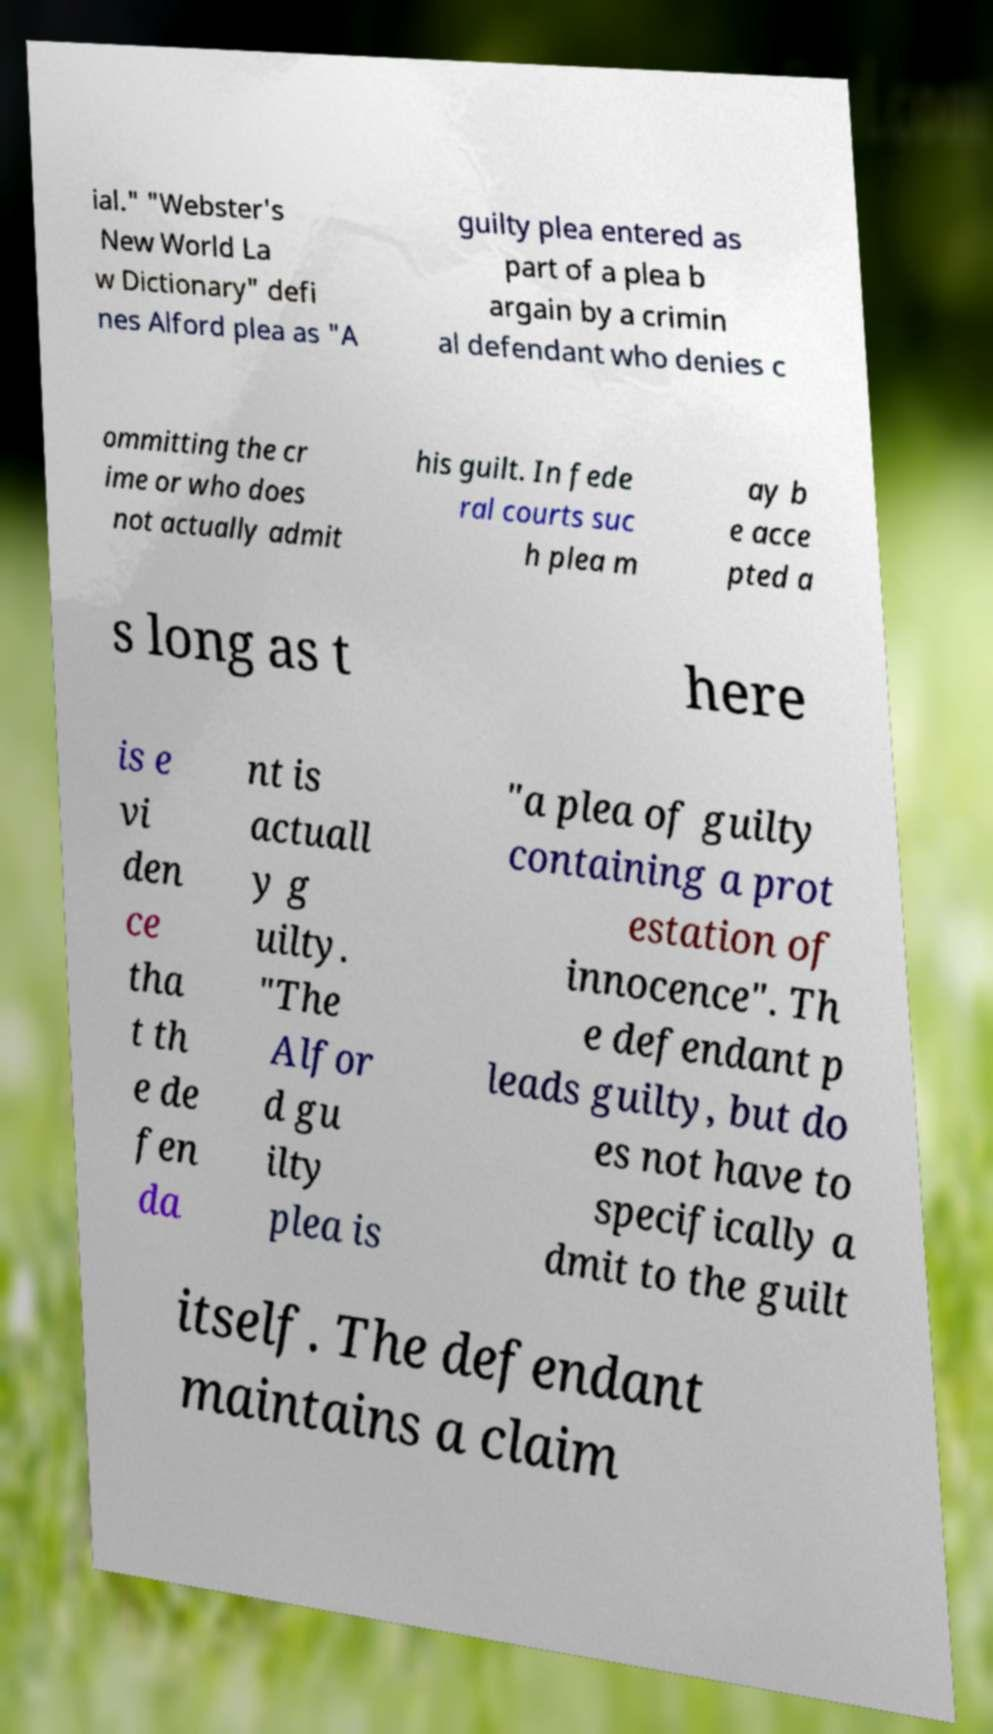I need the written content from this picture converted into text. Can you do that? ial." "Webster's New World La w Dictionary" defi nes Alford plea as "A guilty plea entered as part of a plea b argain by a crimin al defendant who denies c ommitting the cr ime or who does not actually admit his guilt. In fede ral courts suc h plea m ay b e acce pted a s long as t here is e vi den ce tha t th e de fen da nt is actuall y g uilty. "The Alfor d gu ilty plea is "a plea of guilty containing a prot estation of innocence". Th e defendant p leads guilty, but do es not have to specifically a dmit to the guilt itself. The defendant maintains a claim 